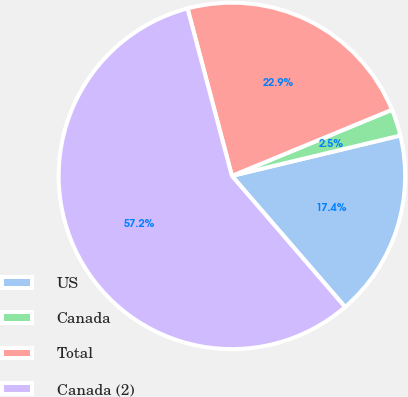<chart> <loc_0><loc_0><loc_500><loc_500><pie_chart><fcel>US<fcel>Canada<fcel>Total<fcel>Canada (2)<nl><fcel>17.41%<fcel>2.49%<fcel>22.89%<fcel>57.21%<nl></chart> 